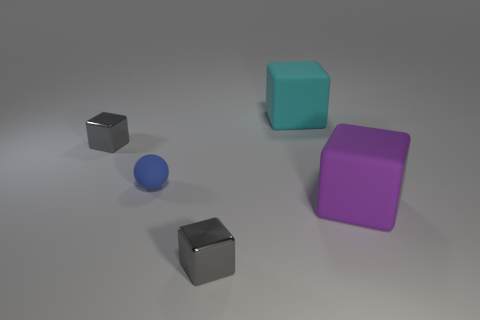Subtract all brown balls. How many gray blocks are left? 2 Add 3 big purple rubber things. How many objects exist? 8 Subtract all large cyan rubber cubes. How many cubes are left? 3 Subtract 1 blocks. How many blocks are left? 3 Subtract all purple cubes. How many cubes are left? 3 Subtract all balls. How many objects are left? 4 Add 3 cyan matte cubes. How many cyan matte cubes exist? 4 Subtract 0 purple cylinders. How many objects are left? 5 Subtract all yellow blocks. Subtract all yellow cylinders. How many blocks are left? 4 Subtract all small gray blocks. Subtract all matte objects. How many objects are left? 0 